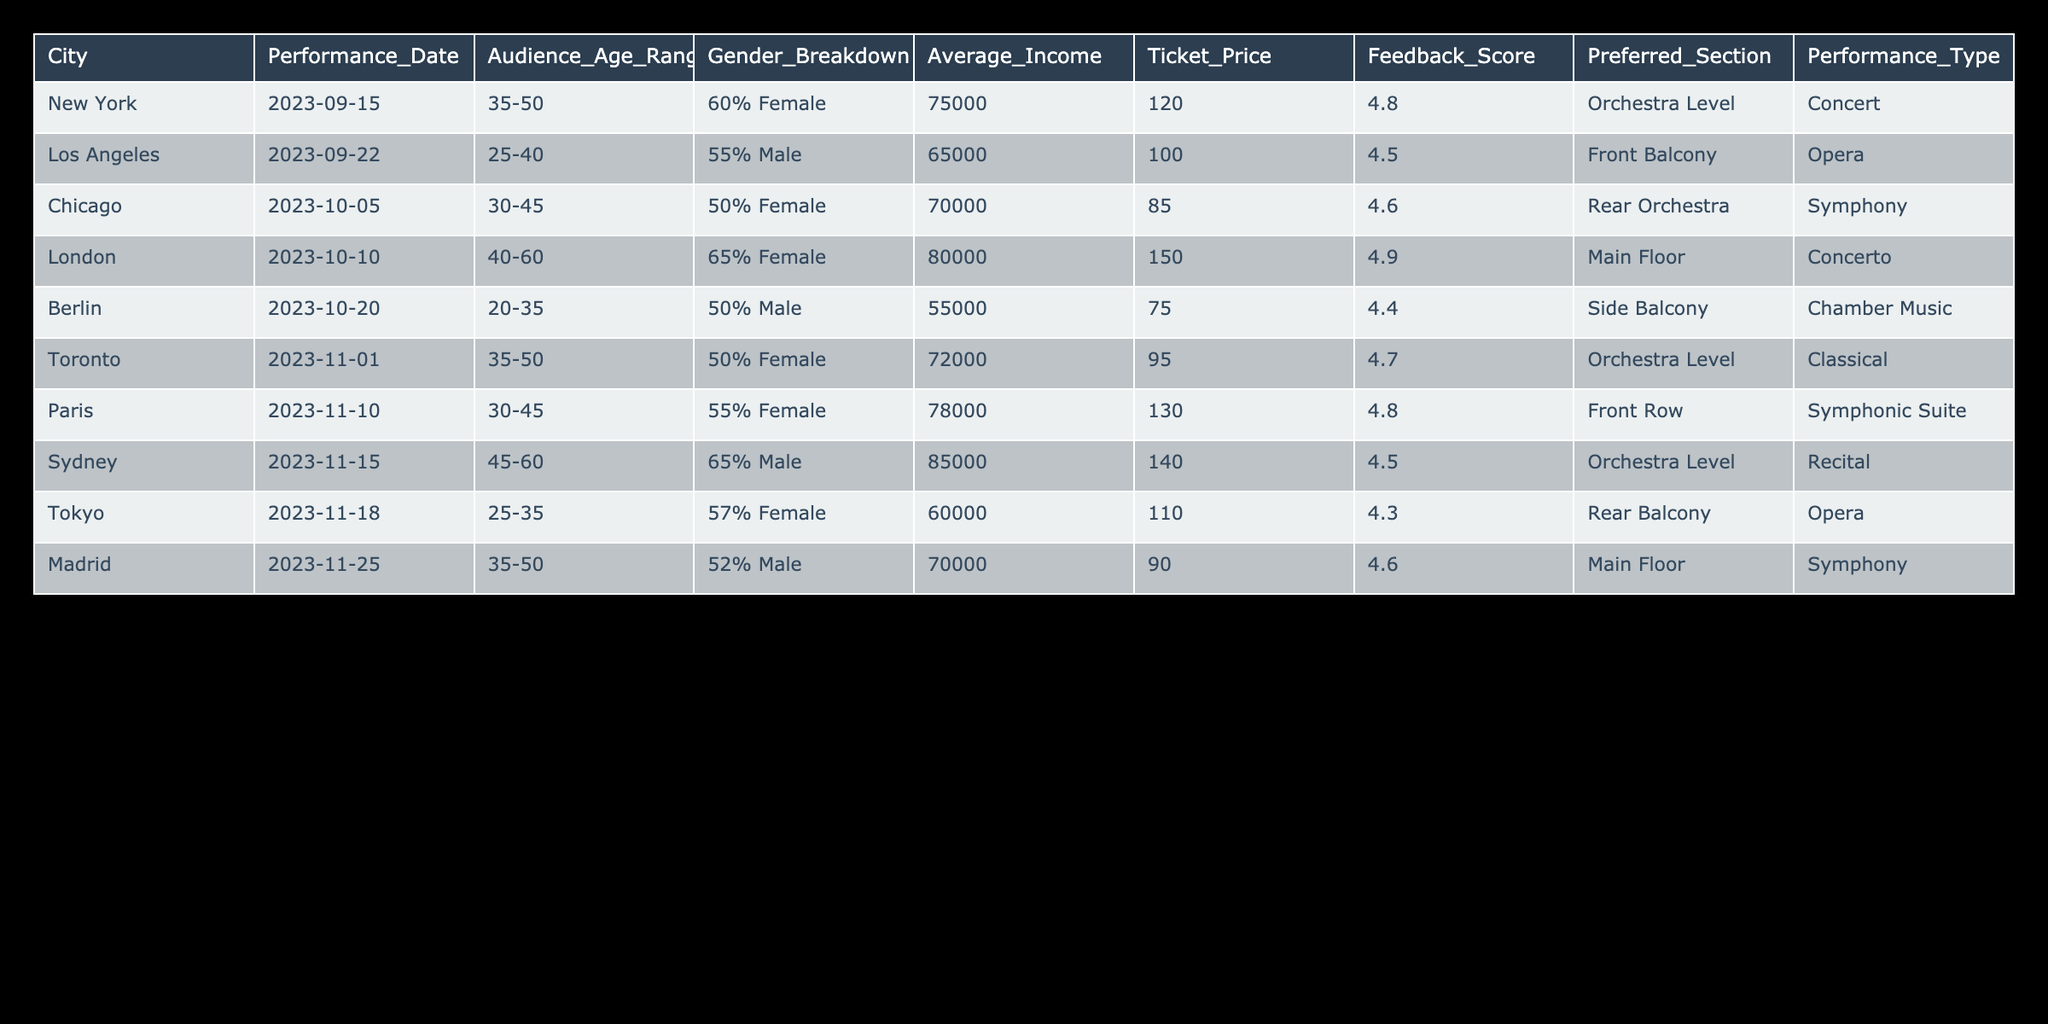What is the feedback score for the performance in London? The table lists the feedback scores for each city, and for London, the score is specified as 4.9.
Answer: 4.9 Which city has the highest average income among the performances listed? The average income column shows that Sydney has the highest average income of 85,000, which is greater than others in the table.
Answer: 85000 What is the ratio of male to female audience in Tokyo? According to the table, the gender breakdown in Tokyo is 57% female, which implies that 43% are male. The male to female ratio can be calculated as 43:57.
Answer: 43:57 What is the average ticket price for performances that received a feedback score of 4.6 or higher? First, we identify the performances with scores of 4.6 or higher: New York (120), Chicago (85), London (150), Toronto (95), Paris (130), and Madrid (90). We sum these ticket prices: 120 + 85 + 150 + 95 + 130 + 90 = 670. There are 6 performances, so the average is calculated as 670/6 = approximately 111.67.
Answer: 111.67 Is the audience age range for the performance in Berlin younger than that in Sydney? The age range for Berlin is 20-35, while for Sydney, it is 45-60. Since 20-35 is indeed younger than 45-60, the answer is yes.
Answer: Yes Which performance type has the highest average ticket price? The ticket prices for each performance type can be averaged. The average ticket prices are: Concert (120), Opera (100), Symphony (85), Concerto (150), Chamber Music (75), Classical (95), Symphonic Suite (130), Recital (140). The highest is for the Concerto at 150.
Answer: Concerto 